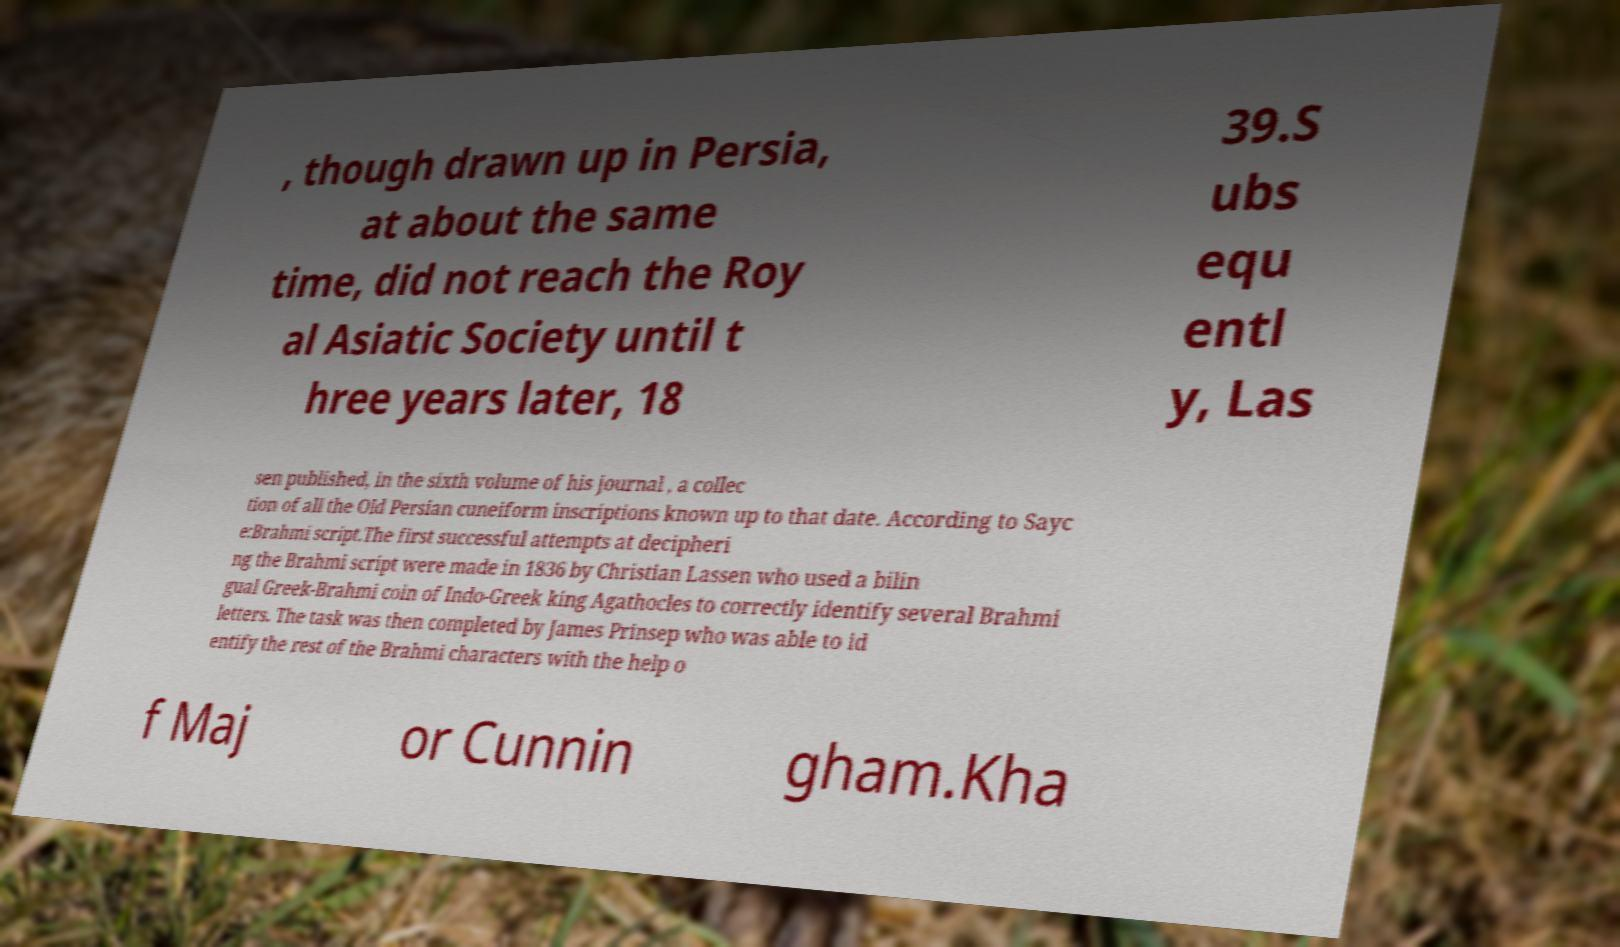Can you read and provide the text displayed in the image?This photo seems to have some interesting text. Can you extract and type it out for me? , though drawn up in Persia, at about the same time, did not reach the Roy al Asiatic Society until t hree years later, 18 39.S ubs equ entl y, Las sen published, in the sixth volume of his journal , a collec tion of all the Old Persian cuneiform inscriptions known up to that date. According to Sayc e:Brahmi script.The first successful attempts at decipheri ng the Brahmi script were made in 1836 by Christian Lassen who used a bilin gual Greek-Brahmi coin of Indo-Greek king Agathocles to correctly identify several Brahmi letters. The task was then completed by James Prinsep who was able to id entify the rest of the Brahmi characters with the help o f Maj or Cunnin gham.Kha 